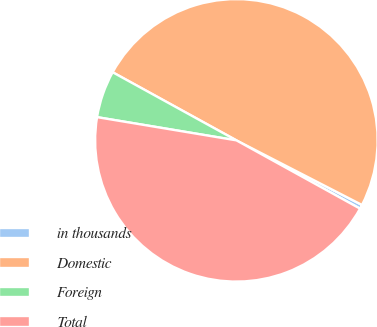Convert chart. <chart><loc_0><loc_0><loc_500><loc_500><pie_chart><fcel>in thousands<fcel>Domestic<fcel>Foreign<fcel>Total<nl><fcel>0.47%<fcel>49.56%<fcel>5.38%<fcel>44.6%<nl></chart> 